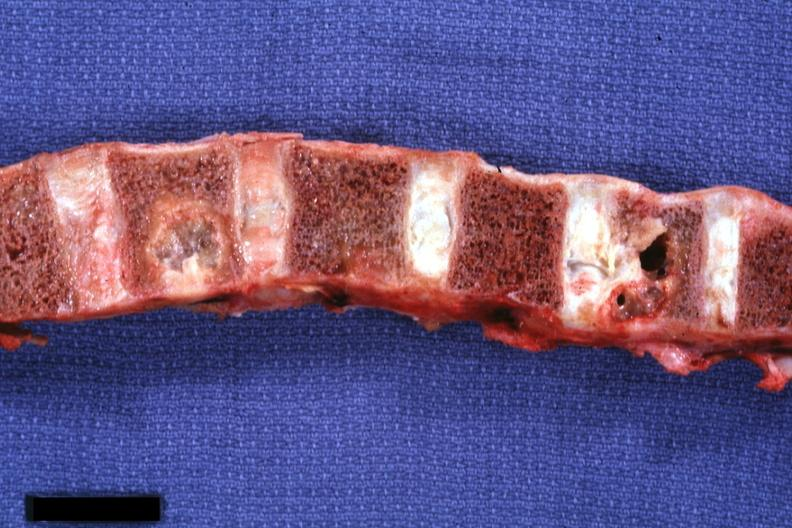what is present?
Answer the question using a single word or phrase. Joints 